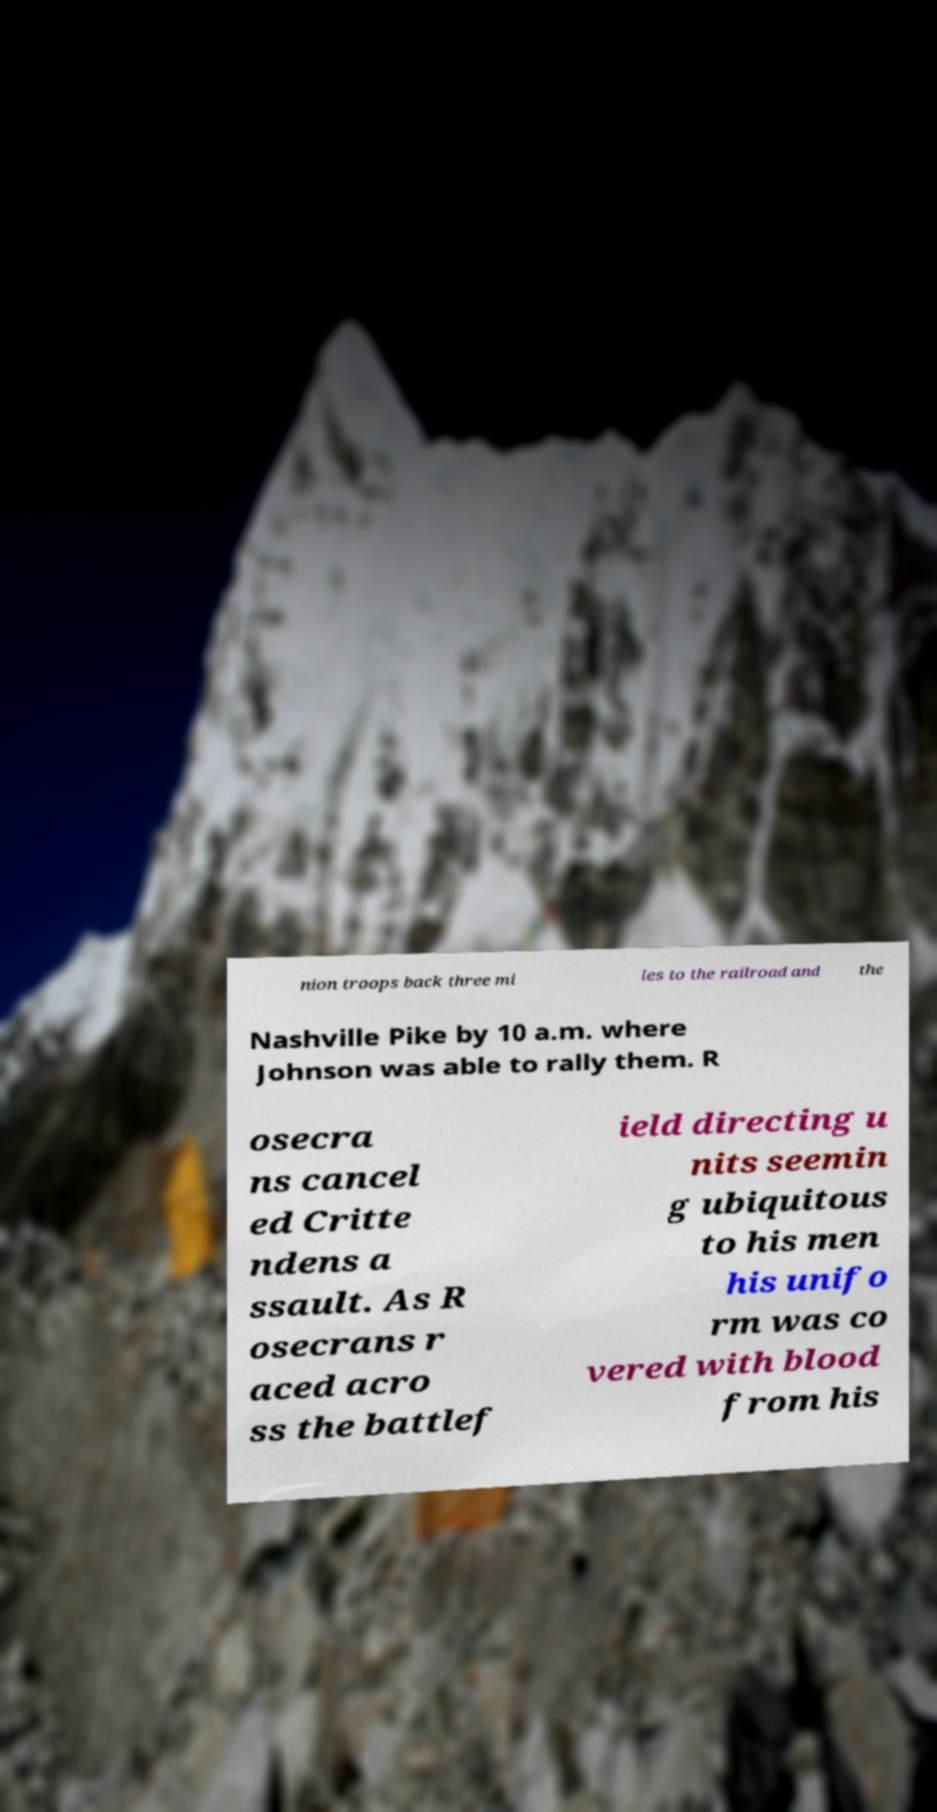Could you extract and type out the text from this image? nion troops back three mi les to the railroad and the Nashville Pike by 10 a.m. where Johnson was able to rally them. R osecra ns cancel ed Critte ndens a ssault. As R osecrans r aced acro ss the battlef ield directing u nits seemin g ubiquitous to his men his unifo rm was co vered with blood from his 